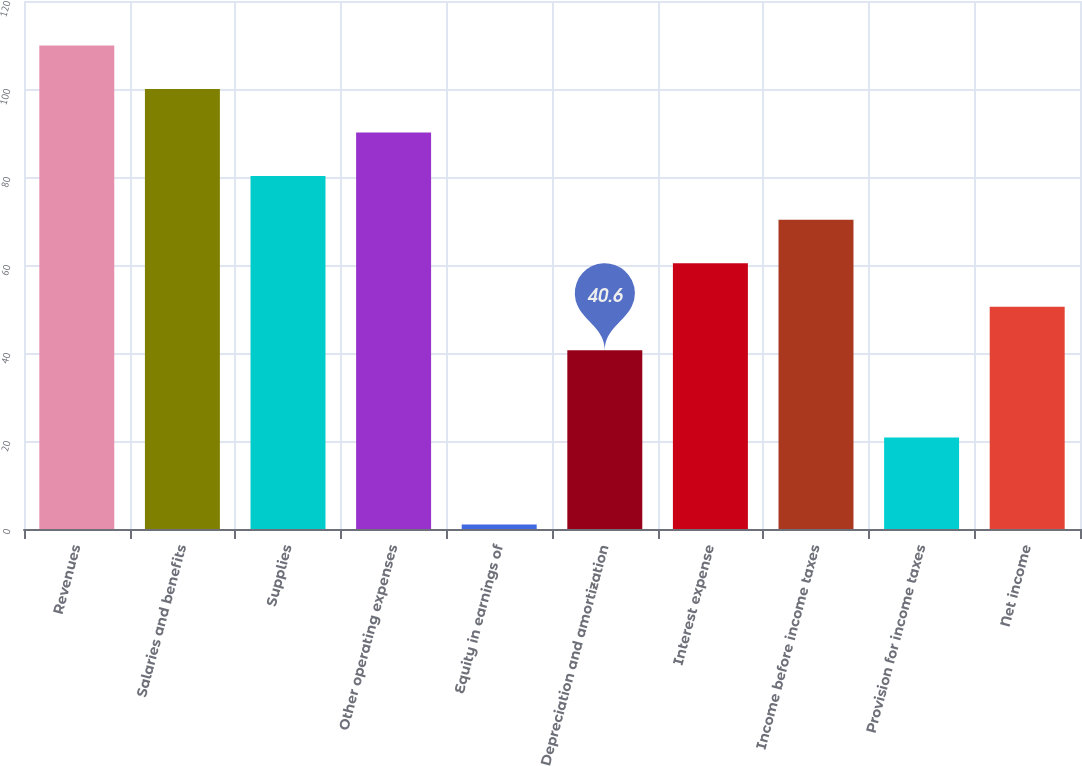Convert chart. <chart><loc_0><loc_0><loc_500><loc_500><bar_chart><fcel>Revenues<fcel>Salaries and benefits<fcel>Supplies<fcel>Other operating expenses<fcel>Equity in earnings of<fcel>Depreciation and amortization<fcel>Interest expense<fcel>Income before income taxes<fcel>Provision for income taxes<fcel>Net income<nl><fcel>109.9<fcel>100<fcel>80.2<fcel>90.1<fcel>1<fcel>40.6<fcel>60.4<fcel>70.3<fcel>20.8<fcel>50.5<nl></chart> 